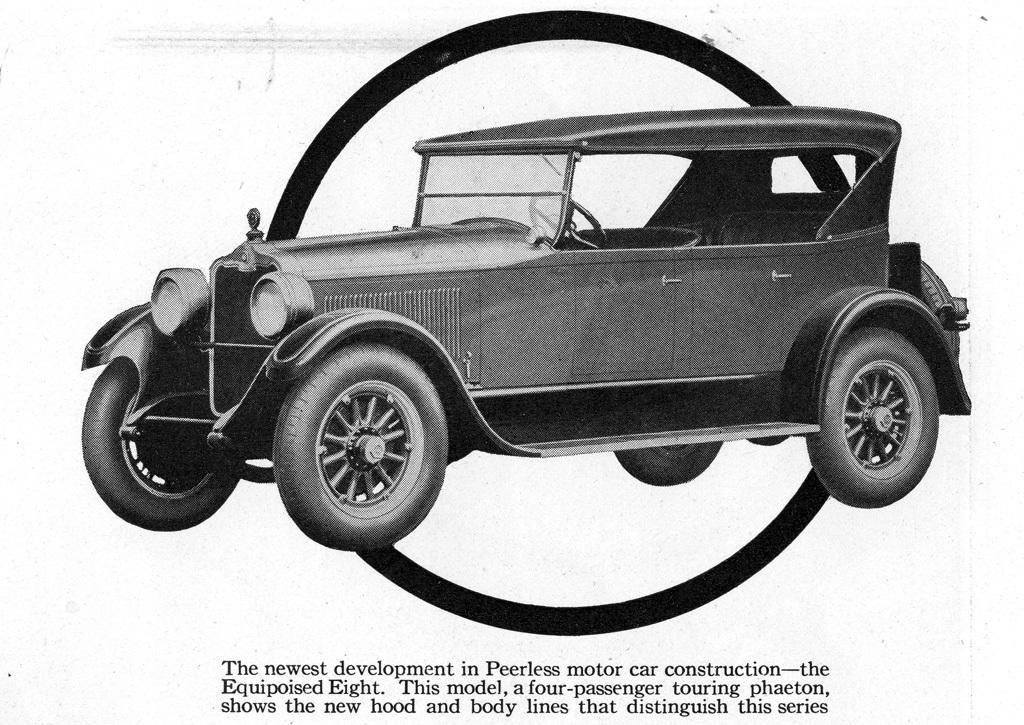Could you give a brief overview of what you see in this image? This is a black and white image of a car, below the car there is a text. 